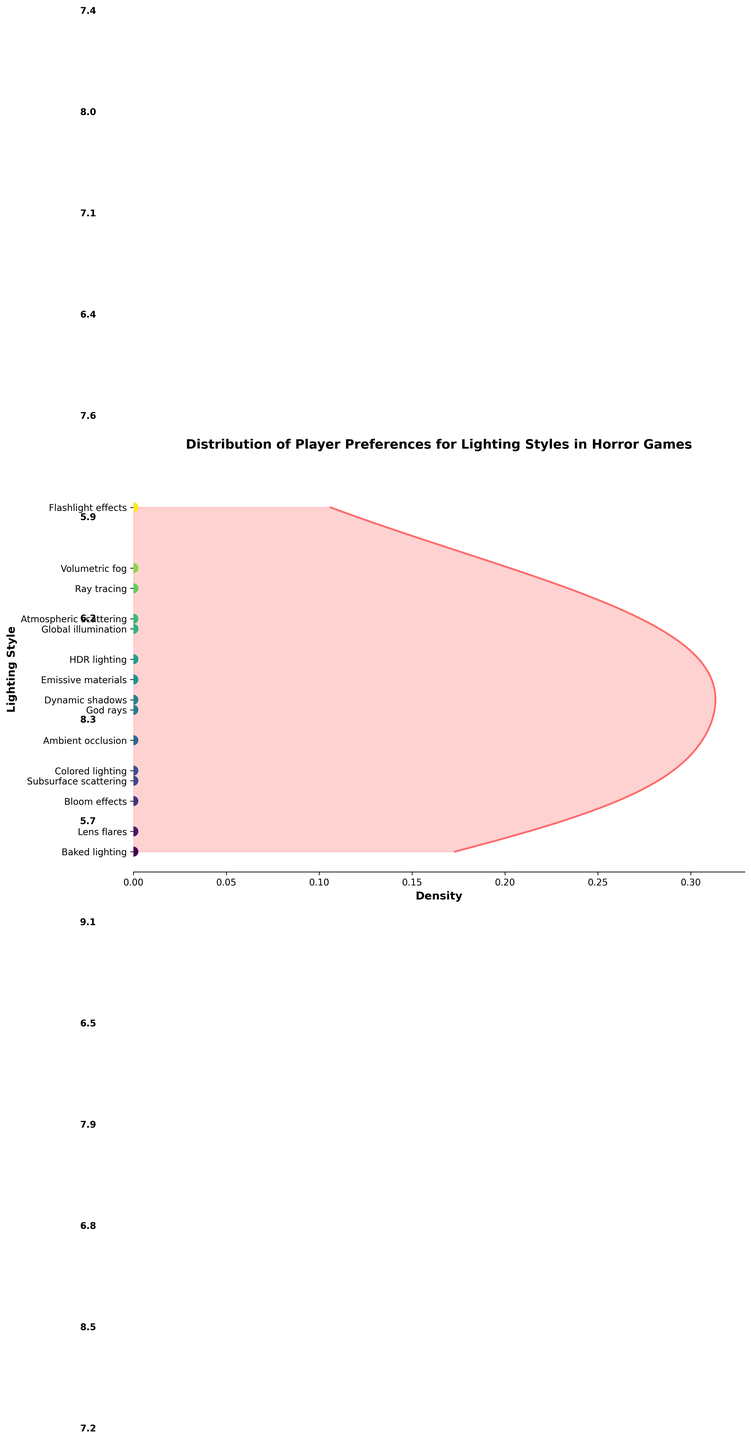What's the title of the plot? The title is usually positioned at the top of the plot and is often used to summarize what the plot is about. In this case, the title is written in bold and clear text.
Answer: Distribution of Player Preferences for Lighting Styles in Horror Games Which lighting style has the highest preference score? Identify the highest point in the y-axis where the lighting styles are listed and look for the corresponding score. In this case, the lighting style "Flashlight effects" has the highest preference score of 9.1.
Answer: Flashlight effects What is the density color used in the plot? The density color can be determined by observing the hue of the plot's filled area. Here it is a vivid red color.
Answer: Red How many lighting styles have a preference score above 8.0? Look at the y-axis labels and count the number of lighting styles with scores above 8.0. Flashlight effects, Volumetric fog, Ray tracing, and Atmospheric scattering have scores above 8.0.
Answer: 4 What is the average preference score for the lighting styles? Sum the preference scores of all lighting styles and then divide by the total number of lighting styles. Sum = 7.2 + 8.5 + 6.8 + 7.9 + 6.5 + 9.1 + 5.7 + 8.3 + 6.2 + 5.9 + 7.6 + 6.4 + 7.1 + 8.0 + 7.4 = 108.6. Average = 108.6 / 15
Answer: 7.24 Which lighting style has the lowest preference score? Find the lowest point on the y-axis and match it to the corresponding label. Here it corresponds to "Baked lighting" which has a score of 5.7.
Answer: Baked lighting Compare the preference scores of "Global illumination" and "HDR lighting." Which one is higher and by how much? Locate both "Global illumination" and "HDR lighting" on the y-axis, note their scores (7.9 for GI and 7.6 for HDR), and subtract the two scores. 7.9 - 7.6 = 0.3
Answer: Global illumination by 0.3 What is the overall trend observed in the density distribution on the plot? The density curve shows how preference scores are distributed, with peaks indicating more preferred lighting styles. Here, the density is higher around scores 7 to 9, suggesting most preference scores fall within this range, signifying these scores are more common among the lighting styles.
Answer: Scores 7 to 9 are more common How does the plot represent individual data points? Individual preference scores are shown as scattered dots along the y-axis with no x-displacement as they cluster near the axis.
Answer: Scattered dots along the y-axis 